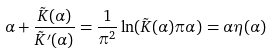<formula> <loc_0><loc_0><loc_500><loc_500>\alpha + \frac { \tilde { K } ( \alpha ) } { \tilde { K } ^ { \prime } ( \alpha ) } = \frac { 1 } { \pi ^ { 2 } } \ln ( \tilde { K } ( \alpha ) \pi \alpha ) = \alpha \eta ( \alpha )</formula> 